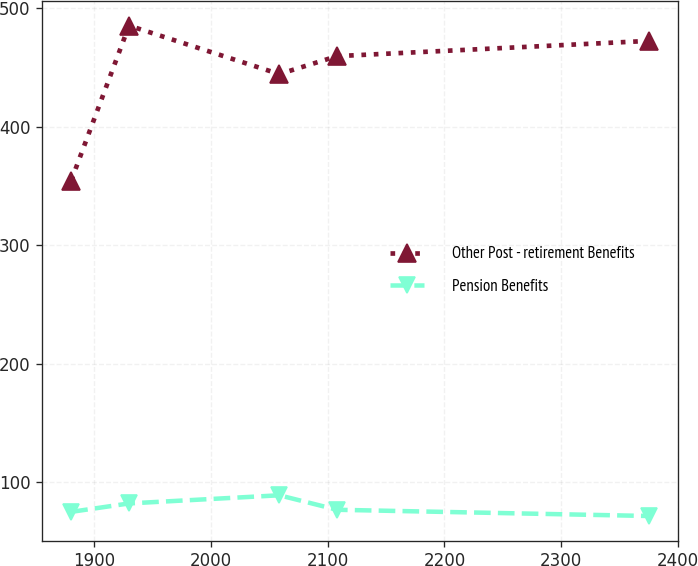Convert chart. <chart><loc_0><loc_0><loc_500><loc_500><line_chart><ecel><fcel>Other Post - retirement Benefits<fcel>Pension Benefits<nl><fcel>1880.11<fcel>354.71<fcel>75.22<nl><fcel>1929.63<fcel>485.37<fcel>82.32<nl><fcel>2058.46<fcel>444.49<fcel>89.2<nl><fcel>2107.98<fcel>459.63<fcel>76.97<nl><fcel>2375.3<fcel>472.5<fcel>71.72<nl></chart> 